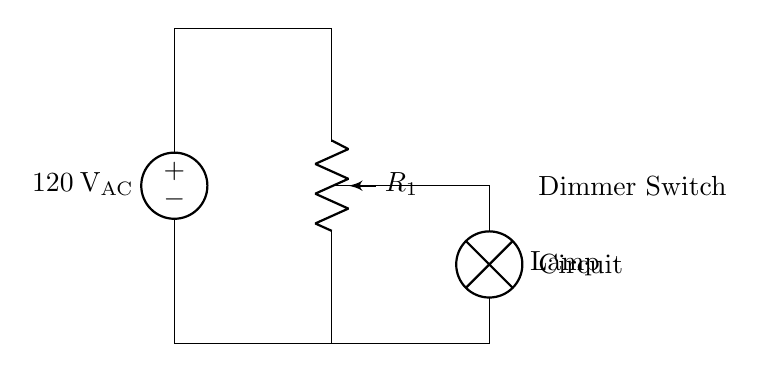What is the input voltage of this circuit? The input voltage is labeled as 120 volts AC, indicated by the voltage source at the top left of the circuit diagram.
Answer: 120 volts AC What type of component is the dimmer switch? The dimmer switch is represented by a potentiometer, which is adjustable and used to control the brightness of the lamp by varying the resistance.
Answer: Potentiometer What is connected in parallel with the lamp? The lamp is connected in parallel with the potentiometer, allowing the voltage divider effect of the potentiometer to dim the lamp light without interrupting the circuit flow.
Answer: Potentiometer How many key components are there in this circuit? The circuit contains three key components: the voltage source, the potentiometer (dimmer switch), and the lamp, all of which play a role in controlling the brightness.
Answer: Three What happens if the resistance of the potentiometer is maximum? If the resistance of the potentiometer is at its maximum, minimal current will flow through the lamp, resulting in it being dimmed significantly or possibly turned off.
Answer: Lamp will dim or turn off What is the purpose of the voltage source in this circuit? The voltage source provides the necessary AC voltage to power the circuit, allowing it to function and supply energy to the lamp for illumination.
Answer: Power the circuit How does turning the dimmer switch affect the lamp? Turning the dimmer switch changes the resistance in the circuit, which alters the voltage across the lamp, resulting in changes to its brightness.
Answer: Changes brightness 